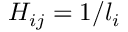Convert formula to latex. <formula><loc_0><loc_0><loc_500><loc_500>H _ { i j } = 1 / l _ { i }</formula> 